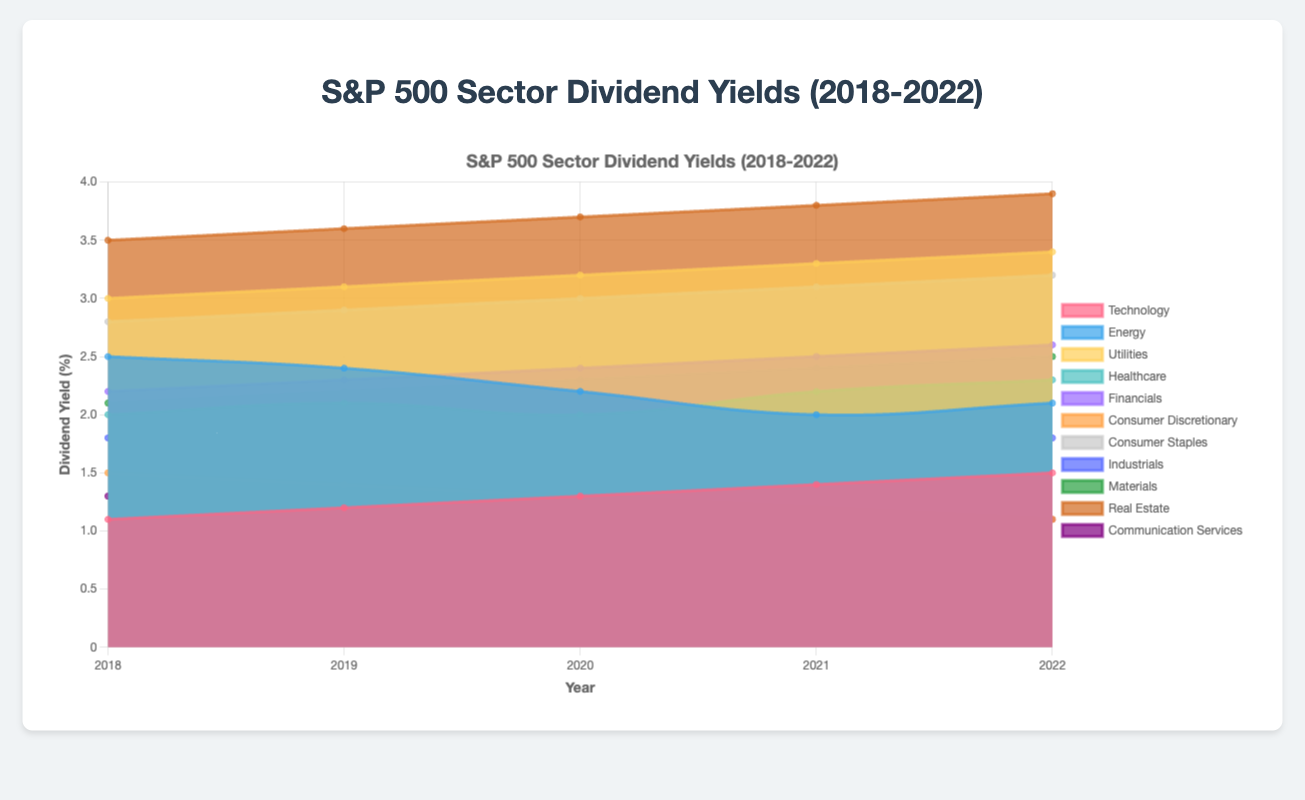What sector had the highest dividend yield in 2022? By looking at the data points for 2022 in the figure, we observe that the Real Estate sector had the highest dividend yield, which was 3.9%.
Answer: Real Estate Which sector shows an increasing trend in dividend yields from 2018 to 2022? The sector that shows consistent year-over-year increases from 2018 to 2022 is the Real Estate sector, where the yields rise from 3.5% to 3.9%.
Answer: Real Estate What is the average dividend yield for the Utilities sector over the five years? Sum the Utilities sector dividend yields for each year: 3.0 + 3.1 + 3.2 + 3.3 + 3.4 = 16.0. Then divide by 5: 16.0 / 5 = 3.2.
Answer: 3.2% How did the dividend yield for the Energy sector change from 2018 to 2020? The dividend yields for the Energy sector in 2018, 2019, and 2020 were 2.5%, 2.4%, and 2.2%, respectively. The yield decreased by 0.3% from 2018 to 2020.
Answer: Decreased by 0.3% Which sector had the lowest dividend yield in 2021? By examining the data points for 2021, the sector with the lowest dividend yield is Communication Services at 1.0%.
Answer: Communication Services How many sectors have a dividend yield greater than 3.0% in 2022? The sectors with dividend yields greater than 3.0% in 2022 are Utilities (3.4%), Consumer Staples (3.2%), and Real Estate (3.9%). There are three sectors in total.
Answer: 3 Compare the dividend yields between Healthcare and Financials for the year 2022. Which one is higher and by how much? In 2022, Healthcare's yield is 2.3%, while Financials' yield is 2.6%. Financials' yield is higher by 0.3%.
Answer: Financials by 0.3% What is the total increase in dividend yield for the Technology sector from 2018 to 2022? The Technology sector's dividend yields for 2018 and 2022 are 1.1% and 1.5%, respectively. The total increase is 1.5% - 1.1% = 0.4%.
Answer: 0.4% Which sector shows a decreasing trend in dividend yields from 2018 to 2021? Consumer Discretionary shows a decreasing trend, with yields going from 1.5% in 2018 to 1.2% in 2021.
Answer: Consumer Discretionary Rank the sectors by their dividend yields in 2019 from highest to lowest. The dividend yields for 2019 from highest to lowest are: Real Estate (3.6%), Utilities (3.1%), Consumer Staples (2.9%), Energy (2.4%), Financials (2.3%), Materials (2.2%), Healthcare (2.1%), Industrials (1.9%), Technology (1.2%), Consumer Discretionary (1.4%), Communication Services (1.2%).
Answer: Real Estate, Utilities, Consumer Staples, Energy, Financials, Materials, Healthcare, Industrials, Technology, Consumer Discretionary, Communication Services 